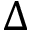Convert formula to latex. <formula><loc_0><loc_0><loc_500><loc_500>\Delta</formula> 